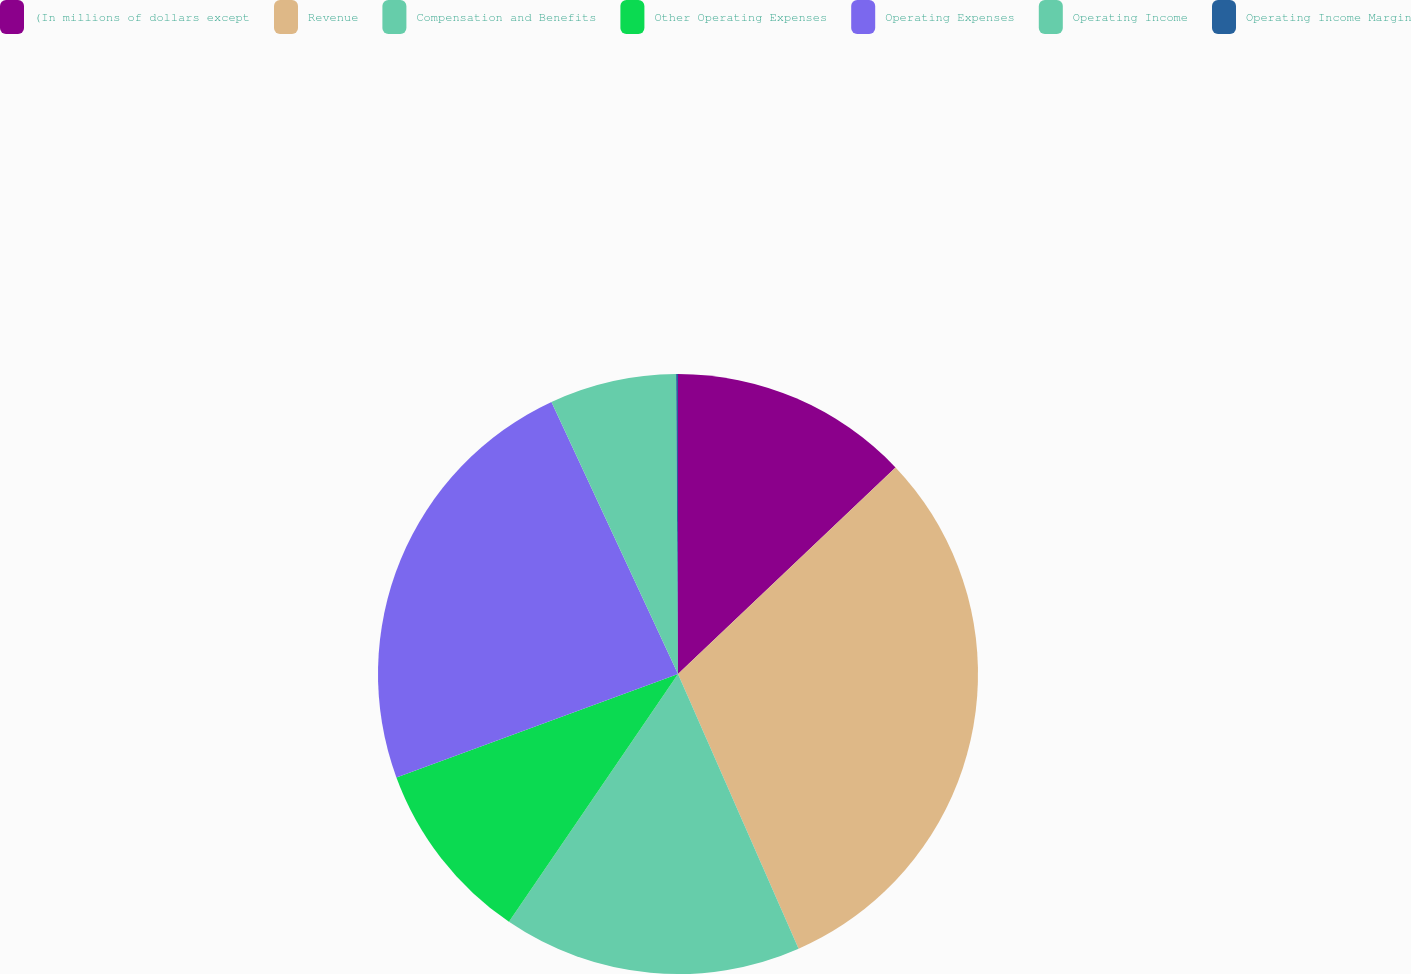Convert chart to OTSL. <chart><loc_0><loc_0><loc_500><loc_500><pie_chart><fcel>(In millions of dollars except<fcel>Revenue<fcel>Compensation and Benefits<fcel>Other Operating Expenses<fcel>Operating Expenses<fcel>Operating Income<fcel>Operating Income Margin<nl><fcel>12.91%<fcel>30.5%<fcel>16.11%<fcel>9.87%<fcel>23.67%<fcel>6.83%<fcel>0.1%<nl></chart> 